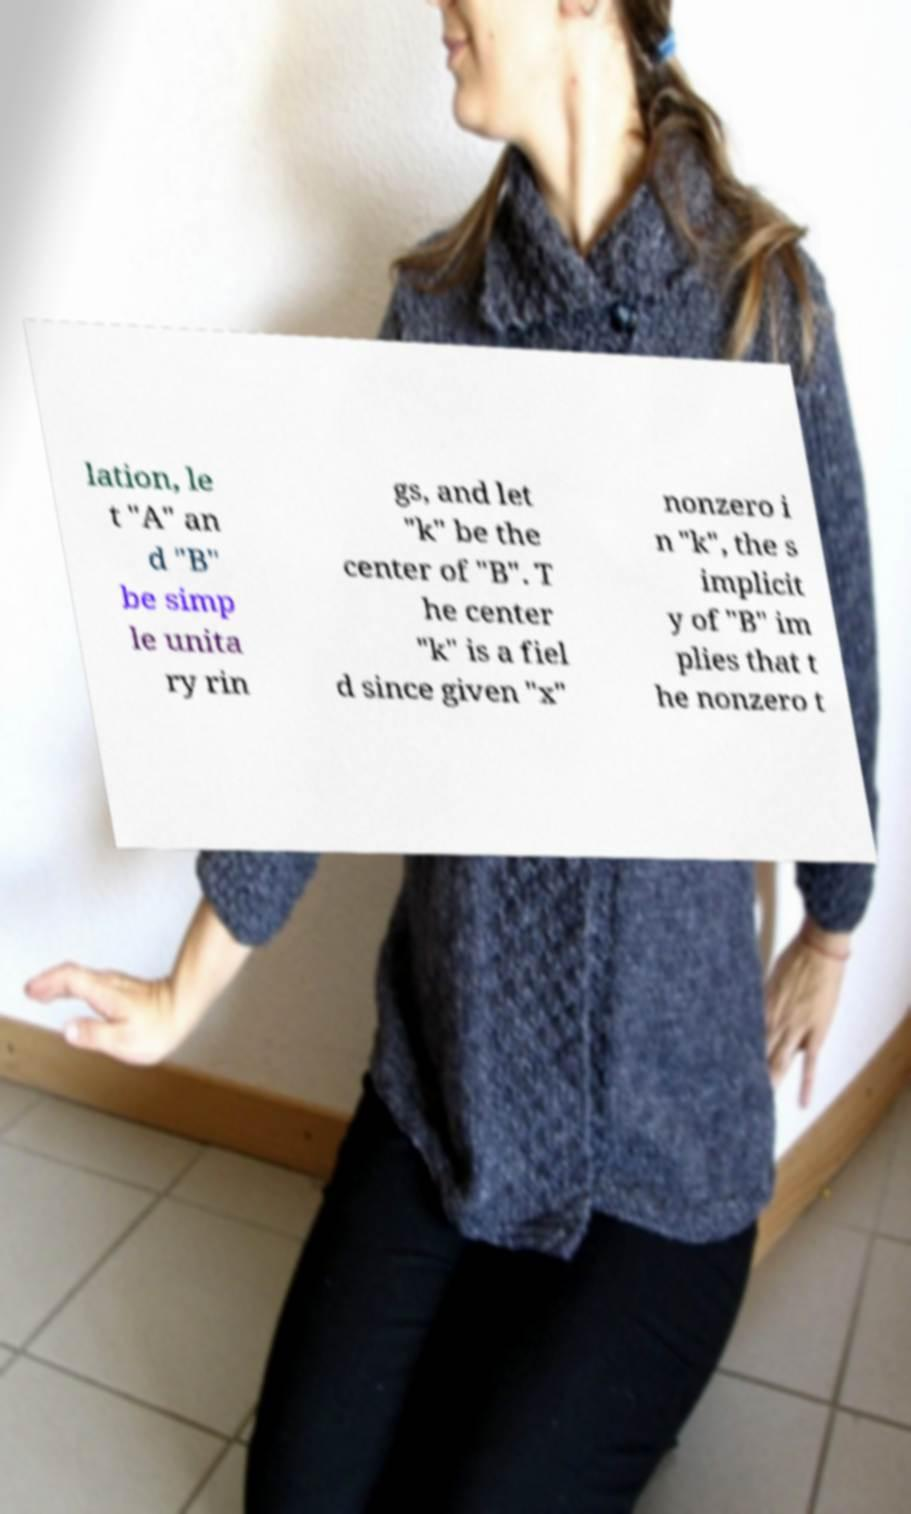Please read and relay the text visible in this image. What does it say? lation, le t "A" an d "B" be simp le unita ry rin gs, and let "k" be the center of "B". T he center "k" is a fiel d since given "x" nonzero i n "k", the s implicit y of "B" im plies that t he nonzero t 